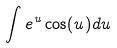<formula> <loc_0><loc_0><loc_500><loc_500>\int e ^ { u } \cos ( u ) d u</formula> 